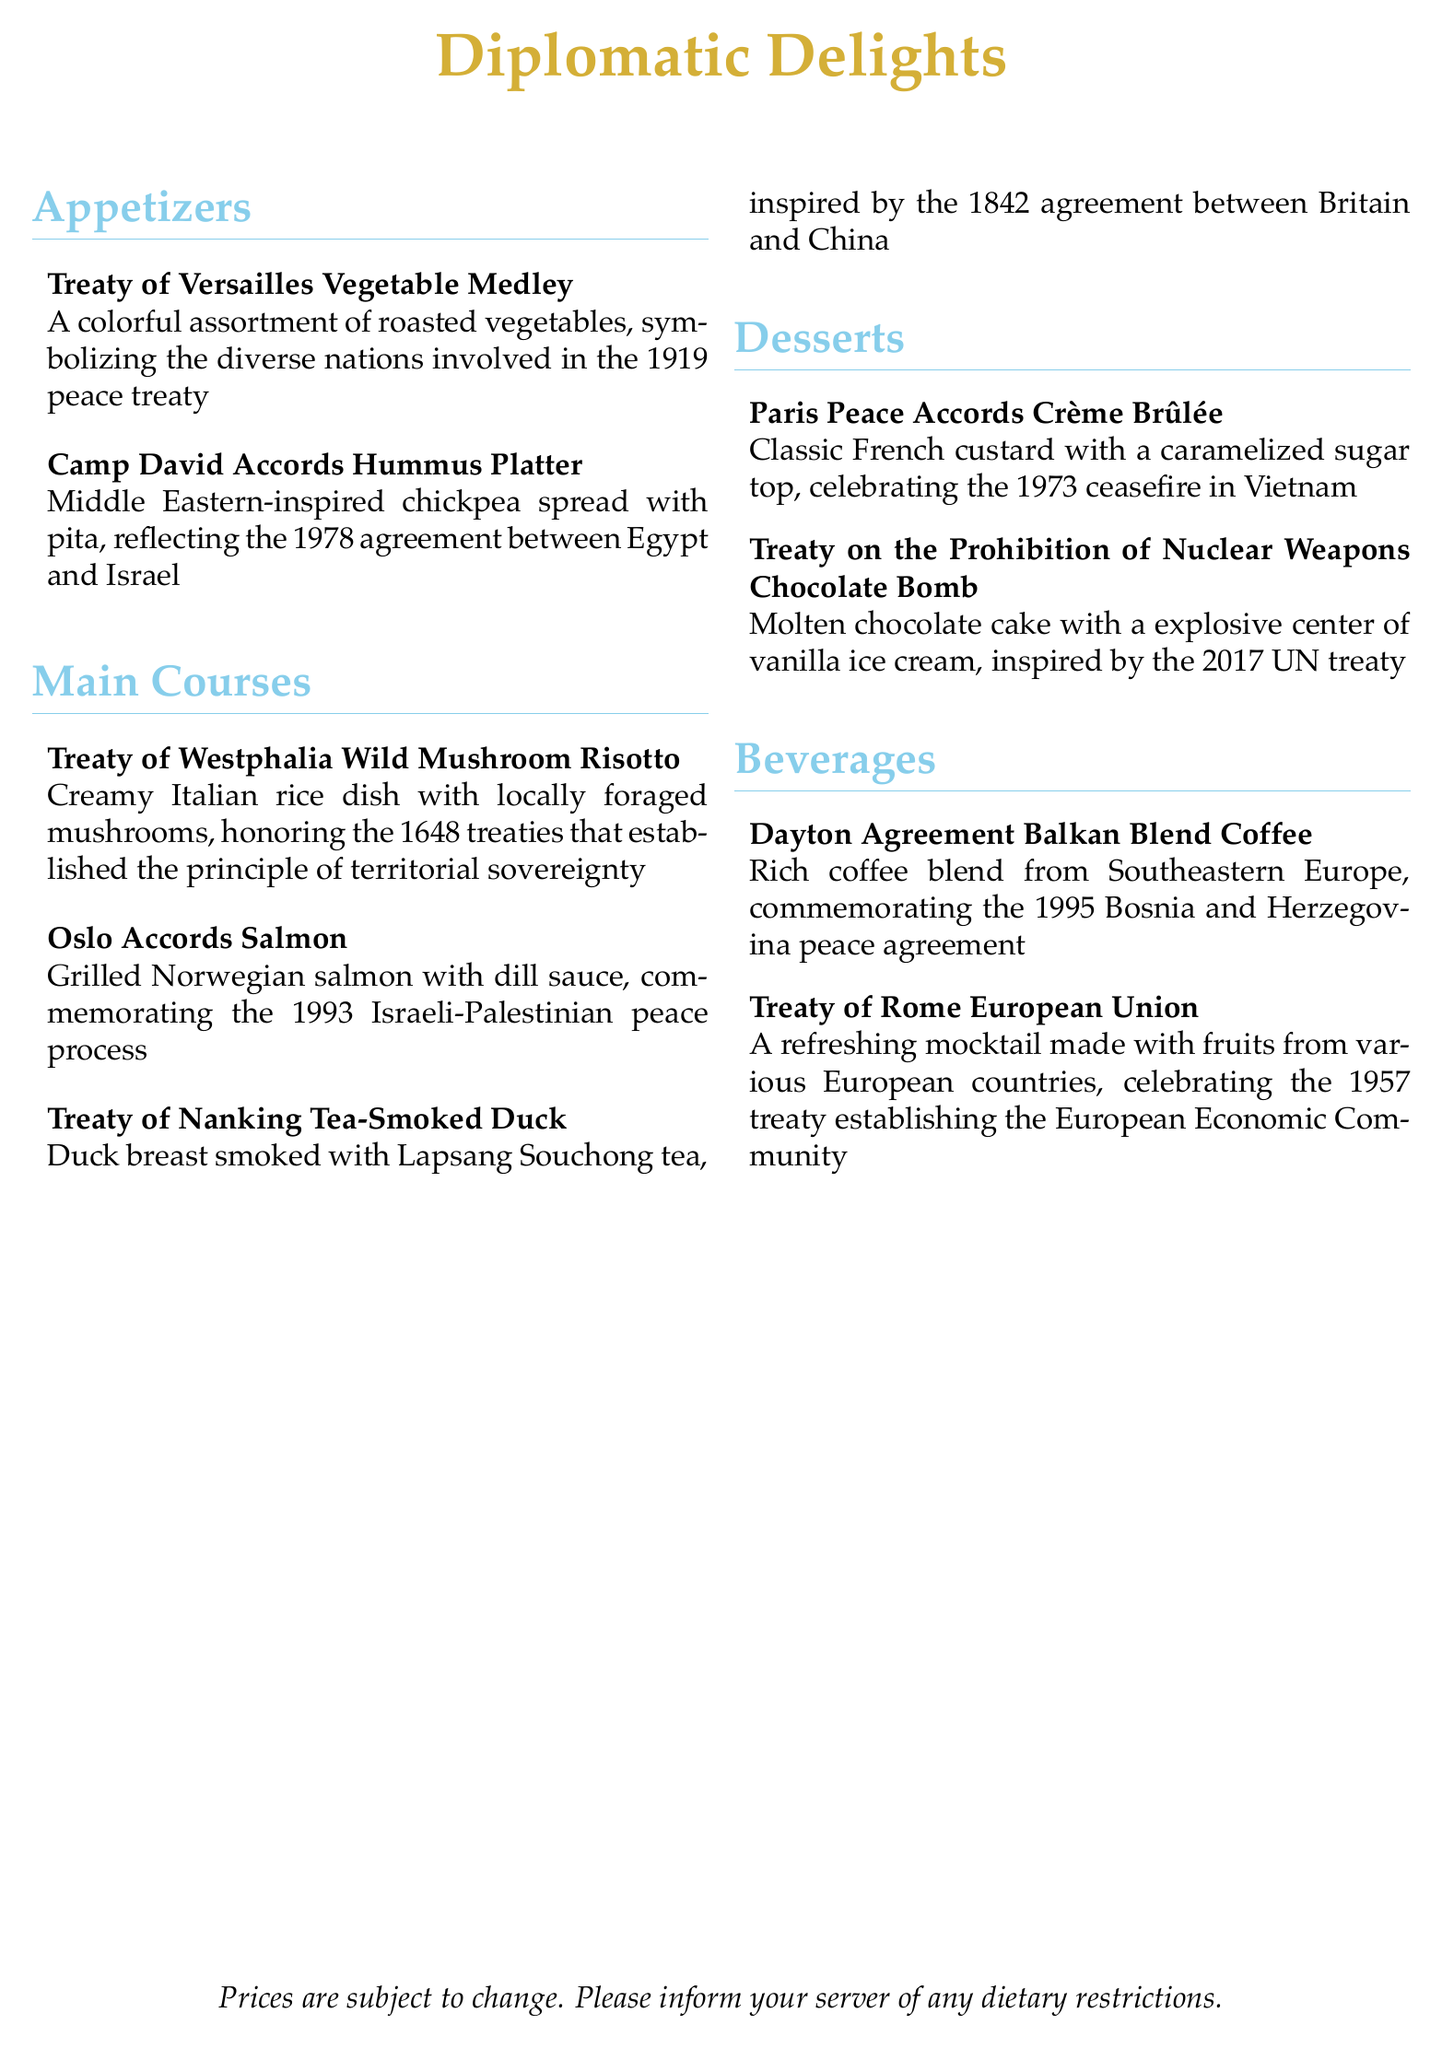What are the appetizers available? The appetizers listed in the menu are the Treaty of Versailles Vegetable Medley and the Camp David Accords Hummus Platter.
Answer: Treaty of Versailles Vegetable Medley, Camp David Accords Hummus Platter What dish commemorates the 1993 Israeli-Palestinian peace process? The dish that commemorates the 1993 Israeli-Palestinian peace process is the Oslo Accords Salmon.
Answer: Oslo Accords Salmon How many desserts are listed on the menu? The menu contains two desserts: the Paris Peace Accords Crème Brûlée and the Treaty on the Prohibition of Nuclear Weapons Chocolate Bomb, which totals two desserts.
Answer: 2 What is the main ingredient in the Camp David Accords Hummus Platter? The main ingredient in the Camp David Accords Hummus Platter is chickpeas, which is used to make the hummus.
Answer: Chickpeas Which treaty inspired the Tea-Smoked Duck dish? The Tea-Smoked Duck dish is inspired by the Treaty of Nanking, which was signed in 1842.
Answer: Treaty of Nanking What type of beverage is the Dayton Agreement? The Dayton Agreement beverage is a rich coffee blend from Southeastern Europe, inspired by a peace agreement.
Answer: Coffee blend What is the dessert associated with the 1973 ceasefire in Vietnam? The dessert associated with the 1973 ceasefire in Vietnam is the Paris Peace Accords Crème Brûlée.
Answer: Paris Peace Accords Crème Brûlée What is the theme of the menu? The theme of the menu is inspired by historical peace treaties, with each dish named after a significant diplomatic agreement.
Answer: Historical peace treaties 